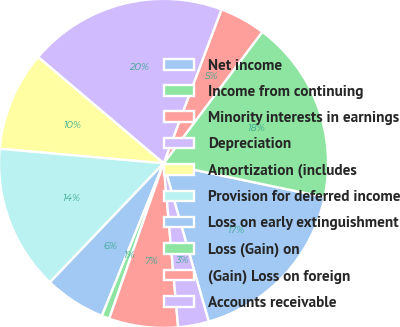Convert chart. <chart><loc_0><loc_0><loc_500><loc_500><pie_chart><fcel>Net income<fcel>Income from continuing<fcel>Minority interests in earnings<fcel>Depreciation<fcel>Amortization (includes<fcel>Provision for deferred income<fcel>Loss on early extinguishment<fcel>Loss (Gain) on<fcel>(Gain) Loss on foreign<fcel>Accounts receivable<nl><fcel>17.29%<fcel>18.04%<fcel>4.52%<fcel>19.54%<fcel>9.77%<fcel>14.28%<fcel>6.02%<fcel>0.76%<fcel>6.77%<fcel>3.01%<nl></chart> 